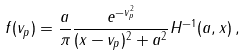Convert formula to latex. <formula><loc_0><loc_0><loc_500><loc_500>f ( v _ { p } ) = \frac { a } { \pi } \frac { e ^ { - v _ { p } ^ { 2 } } } { ( x - v _ { p } ) ^ { 2 } + a ^ { 2 } } H ^ { - 1 } ( a , x ) \, ,</formula> 